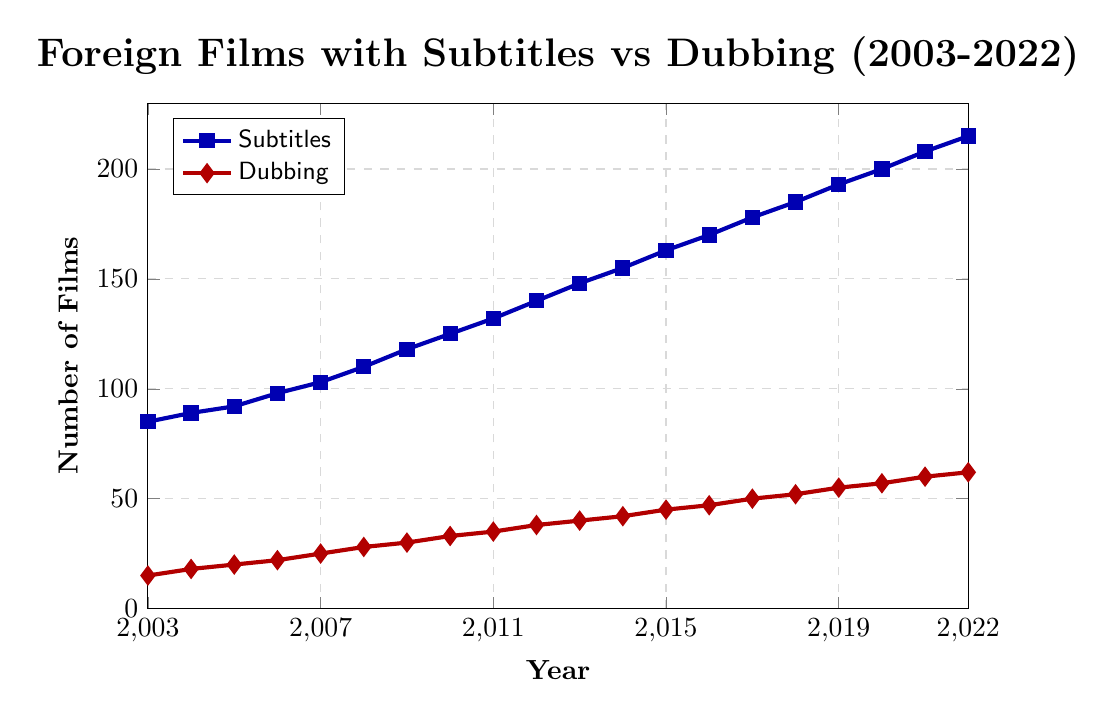What is the trend in the number of foreign films released with subtitles from 2003 to 2022? The blue line representing "Foreign Films with Subtitles" shows a steady upward trend from 85 in 2003 to 215 in 2022.
Answer: Steady upward trend Which year saw the greatest increase in the number of subtitled films compared to the previous year? By visually examining the blue line, the year 2012 to 2013 shows a noticeable jump, from 140 to 148, a difference of 8.
Answer: 2012 to 2013 Comparing 2003 and 2022, how much more foreign films were released with dubbing in 2022? In 2003, 15 films were dubbed, and in 2022, 62 films were dubbed. The increase is 62 - 15 = 47.
Answer: 47 What is the average number of foreign films released with subtitles from 2003 to 2022? Sum the numbers for each year from 2003 to 2022 and divide by 20 ( (85 + 89 + 92 + ... + 215) ÷ 20 ). Performing the calculation: 2940 ÷ 20 = 147.
Answer: 147 What is the difference between the number of films released with subtitles and dubbing in 2020? In 2020, there were 200 films with subtitles and 57 films with dubbing. The difference is 200 - 57 = 143.
Answer: 143 Which line uses diamond marks to represent data points? Visually inspecting the plot, the red line representing "Foreign Films with Dubbing" uses diamond-shaped marks.
Answer: Foreign Films with Dubbing Which color represents the number of foreign films released with subtitles? The blue line in the plot represents the number of foreign films with subtitles.
Answer: Blue In which year did the number of dubbed foreign films reach 50? The red line representing "Foreign Films with Dubbing" intersects the 50 mark in 2017.
Answer: 2017 What is the total number of foreign films released with subtitles and dubbing in 2015? In 2015, there were 163 films with subtitles and 45 films with dubbing. The total is 163 + 45 = 208.
Answer: 208 From the visual representation, which type of films (subtitled or dubbed) has shown a more significant increase overall? The blue line representing subtitled films has a steeper slope compared to the red line representing dubbed films, indicating a more significant overall increase.
Answer: Subtitled films 